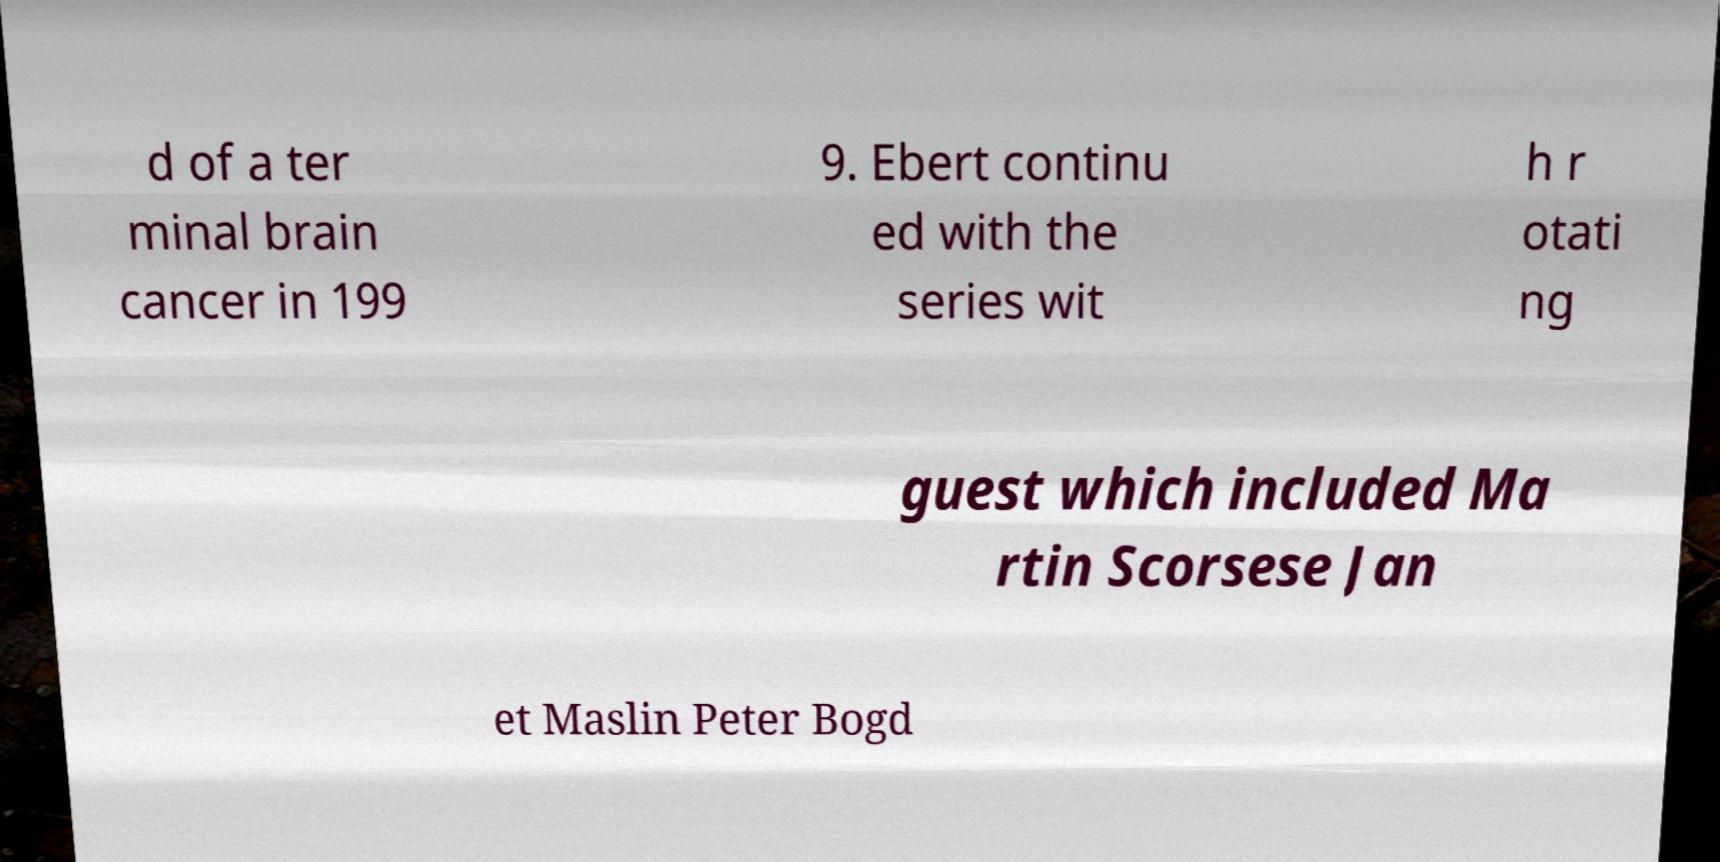I need the written content from this picture converted into text. Can you do that? d of a ter minal brain cancer in 199 9. Ebert continu ed with the series wit h r otati ng guest which included Ma rtin Scorsese Jan et Maslin Peter Bogd 